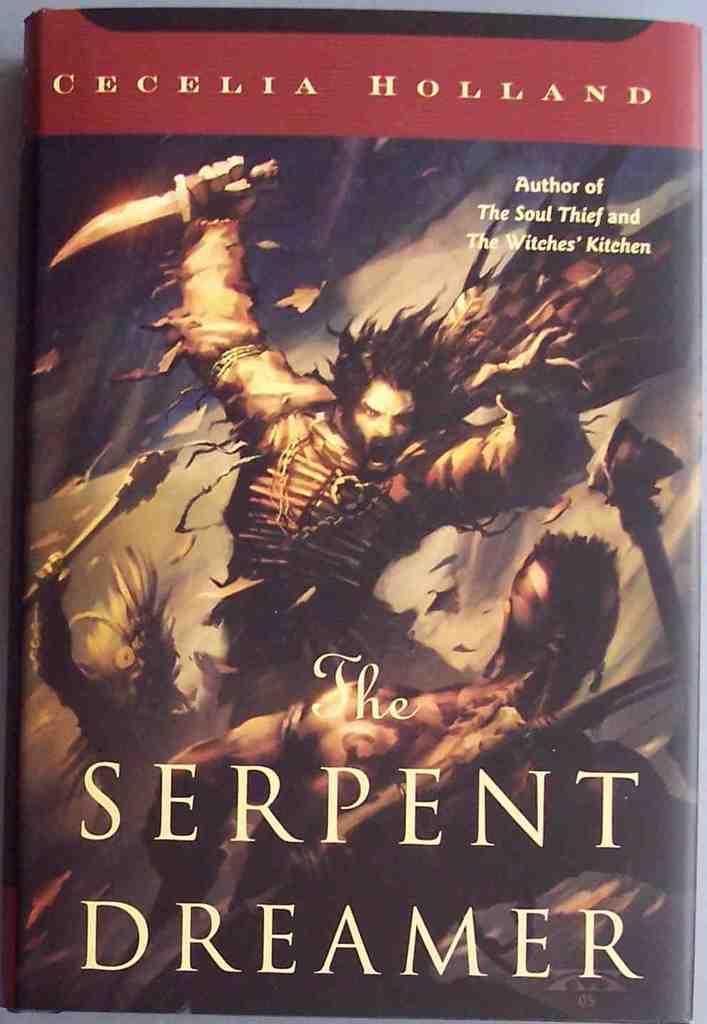Describe this image in one or two sentences. In this picture, we can see a book. On the book, we can see some text written on it, we can also see a painting of man holding weapons in his hand. 